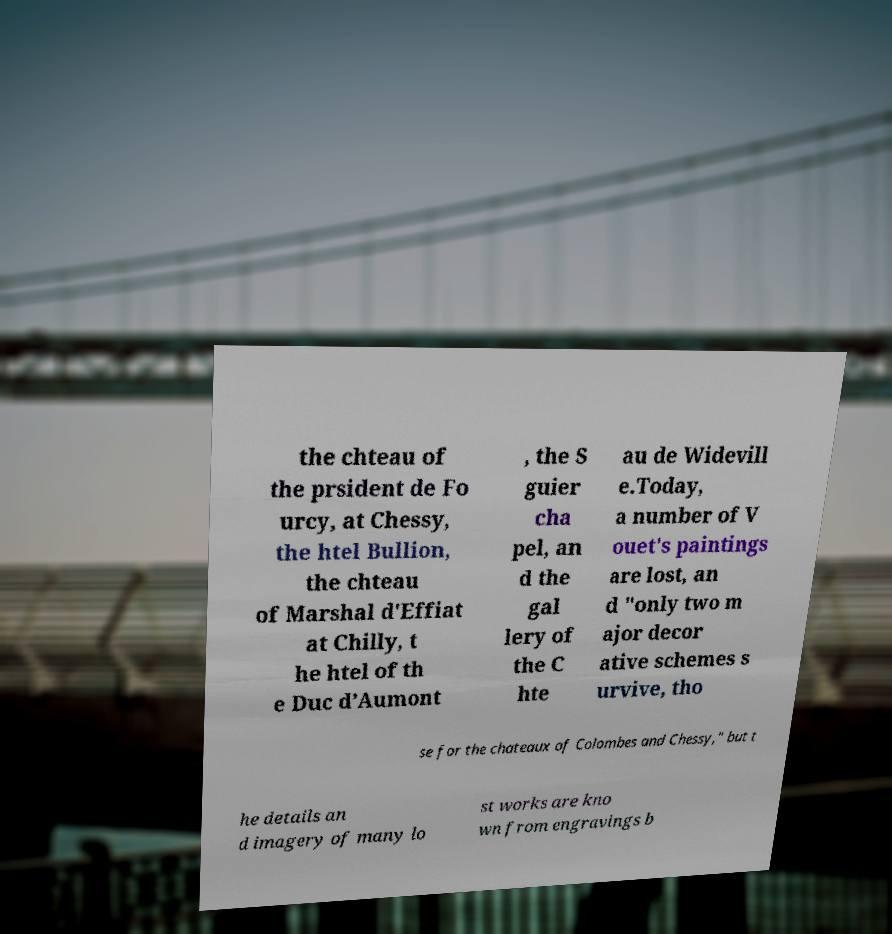There's text embedded in this image that I need extracted. Can you transcribe it verbatim? the chteau of the prsident de Fo urcy, at Chessy, the htel Bullion, the chteau of Marshal d'Effiat at Chilly, t he htel of th e Duc d’Aumont , the S guier cha pel, an d the gal lery of the C hte au de Widevill e.Today, a number of V ouet's paintings are lost, an d "only two m ajor decor ative schemes s urvive, tho se for the chateaux of Colombes and Chessy," but t he details an d imagery of many lo st works are kno wn from engravings b 